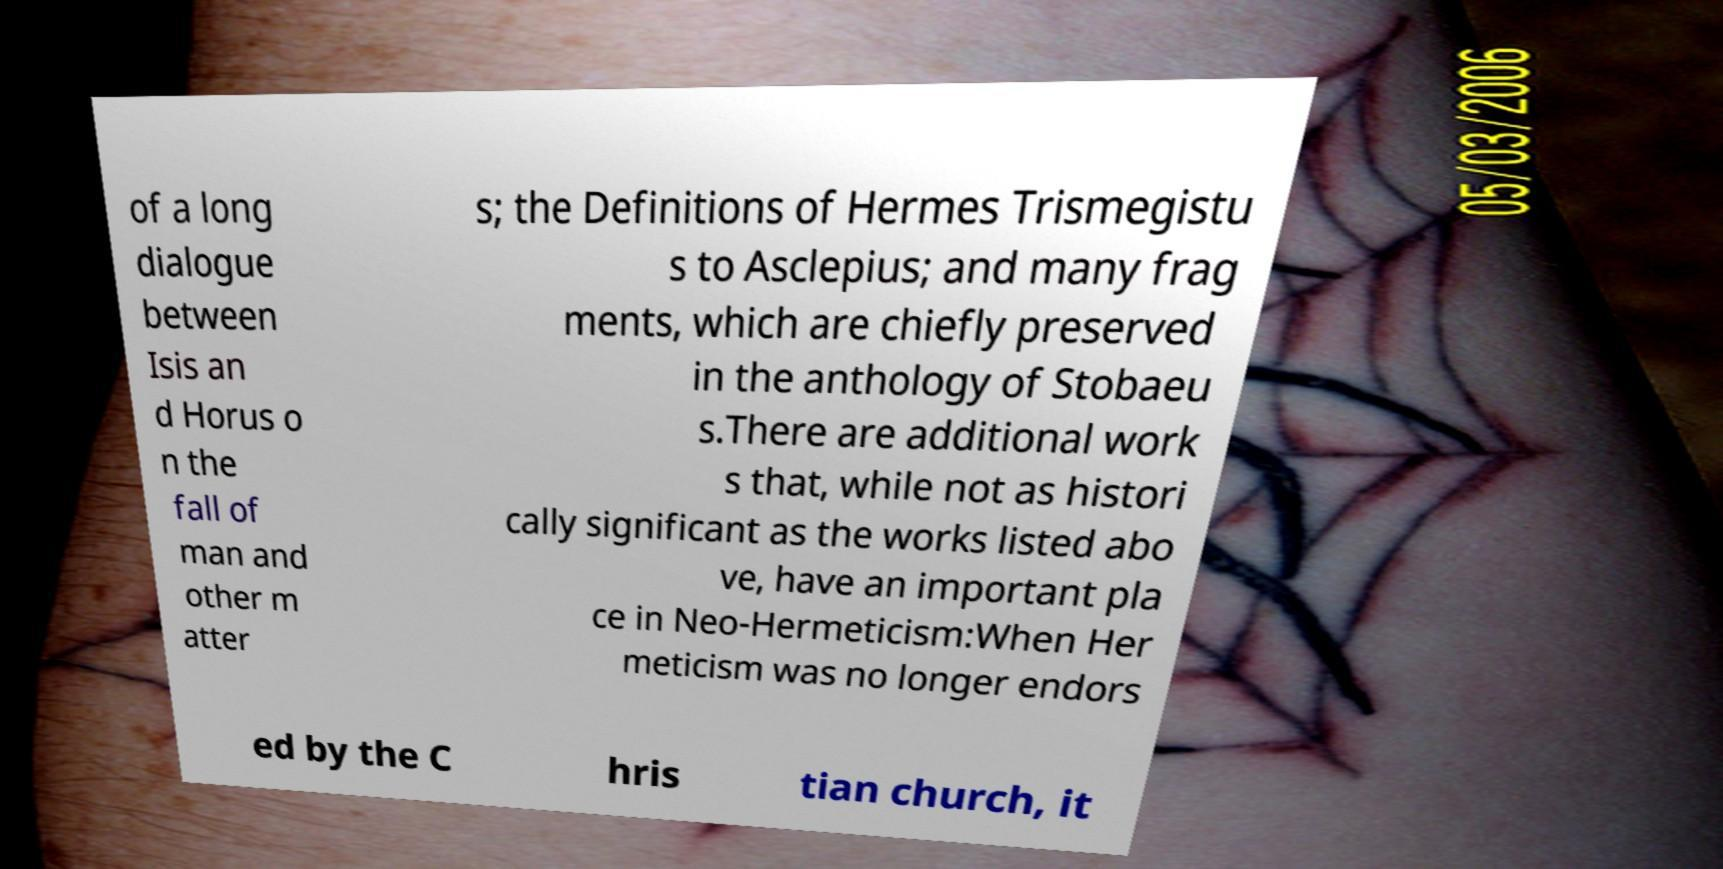Please read and relay the text visible in this image. What does it say? of a long dialogue between Isis an d Horus o n the fall of man and other m atter s; the Definitions of Hermes Trismegistu s to Asclepius; and many frag ments, which are chiefly preserved in the anthology of Stobaeu s.There are additional work s that, while not as histori cally significant as the works listed abo ve, have an important pla ce in Neo-Hermeticism:When Her meticism was no longer endors ed by the C hris tian church, it 